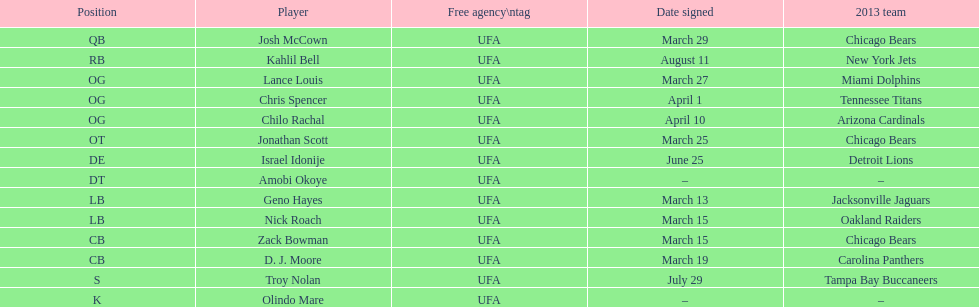Could you parse the entire table as a dict? {'header': ['Position', 'Player', 'Free agency\\ntag', 'Date signed', '2013 team'], 'rows': [['QB', 'Josh McCown', 'UFA', 'March 29', 'Chicago Bears'], ['RB', 'Kahlil Bell', 'UFA', 'August 11', 'New York Jets'], ['OG', 'Lance Louis', 'UFA', 'March 27', 'Miami Dolphins'], ['OG', 'Chris Spencer', 'UFA', 'April 1', 'Tennessee Titans'], ['OG', 'Chilo Rachal', 'UFA', 'April 10', 'Arizona Cardinals'], ['OT', 'Jonathan Scott', 'UFA', 'March 25', 'Chicago Bears'], ['DE', 'Israel Idonije', 'UFA', 'June 25', 'Detroit Lions'], ['DT', 'Amobi Okoye', 'UFA', '–', '–'], ['LB', 'Geno Hayes', 'UFA', 'March 13', 'Jacksonville Jaguars'], ['LB', 'Nick Roach', 'UFA', 'March 15', 'Oakland Raiders'], ['CB', 'Zack Bowman', 'UFA', 'March 15', 'Chicago Bears'], ['CB', 'D. J. Moore', 'UFA', 'March 19', 'Carolina Panthers'], ['S', 'Troy Nolan', 'UFA', 'July 29', 'Tampa Bay Buccaneers'], ['K', 'Olindo Mare', 'UFA', '–', '–']]} During march, how many players were acquired through signing? 7. 